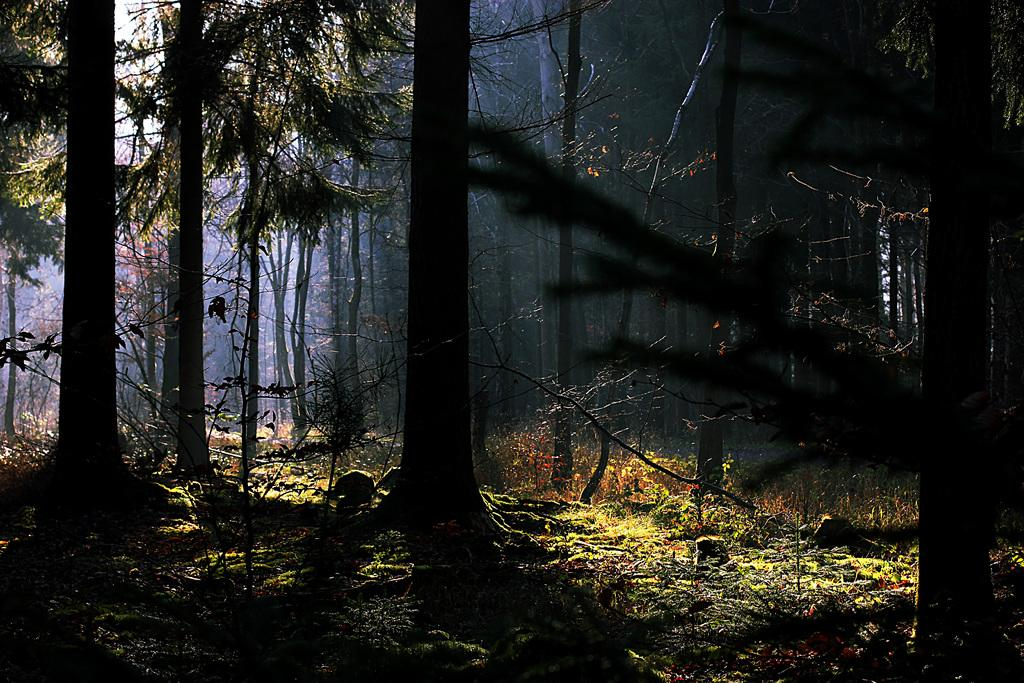What type of environment is depicted in the image? The image appears to depict a forest. What can be seen on the ground in the image? There are many trees on the ground in the image. What type of vegetation is visible in the image? Grass is visible in the image. Are there any other types of plants in the image besides trees and grass? Yes, there are plants in the image. What color is the chalk used to draw on the sheet in the image? There is no chalk or sheet present in the image; it depicts a forest with trees, grass, and plants. 